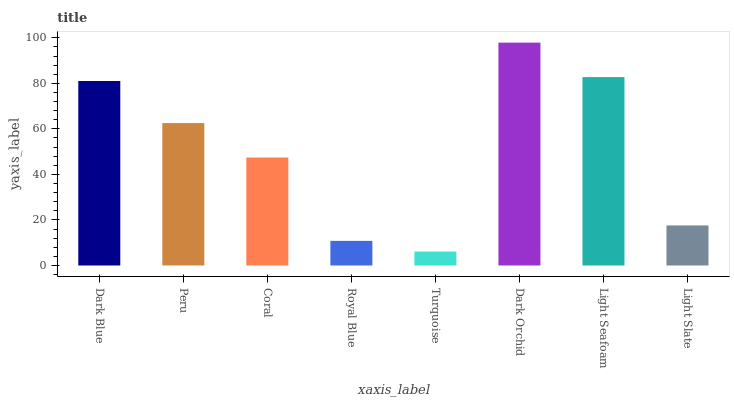Is Turquoise the minimum?
Answer yes or no. Yes. Is Dark Orchid the maximum?
Answer yes or no. Yes. Is Peru the minimum?
Answer yes or no. No. Is Peru the maximum?
Answer yes or no. No. Is Dark Blue greater than Peru?
Answer yes or no. Yes. Is Peru less than Dark Blue?
Answer yes or no. Yes. Is Peru greater than Dark Blue?
Answer yes or no. No. Is Dark Blue less than Peru?
Answer yes or no. No. Is Peru the high median?
Answer yes or no. Yes. Is Coral the low median?
Answer yes or no. Yes. Is Dark Blue the high median?
Answer yes or no. No. Is Royal Blue the low median?
Answer yes or no. No. 